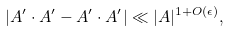<formula> <loc_0><loc_0><loc_500><loc_500>| A ^ { \prime } \cdot A ^ { \prime } - A ^ { \prime } \cdot A ^ { \prime } | \ll | A | ^ { 1 + O ( \epsilon ) } ,</formula> 